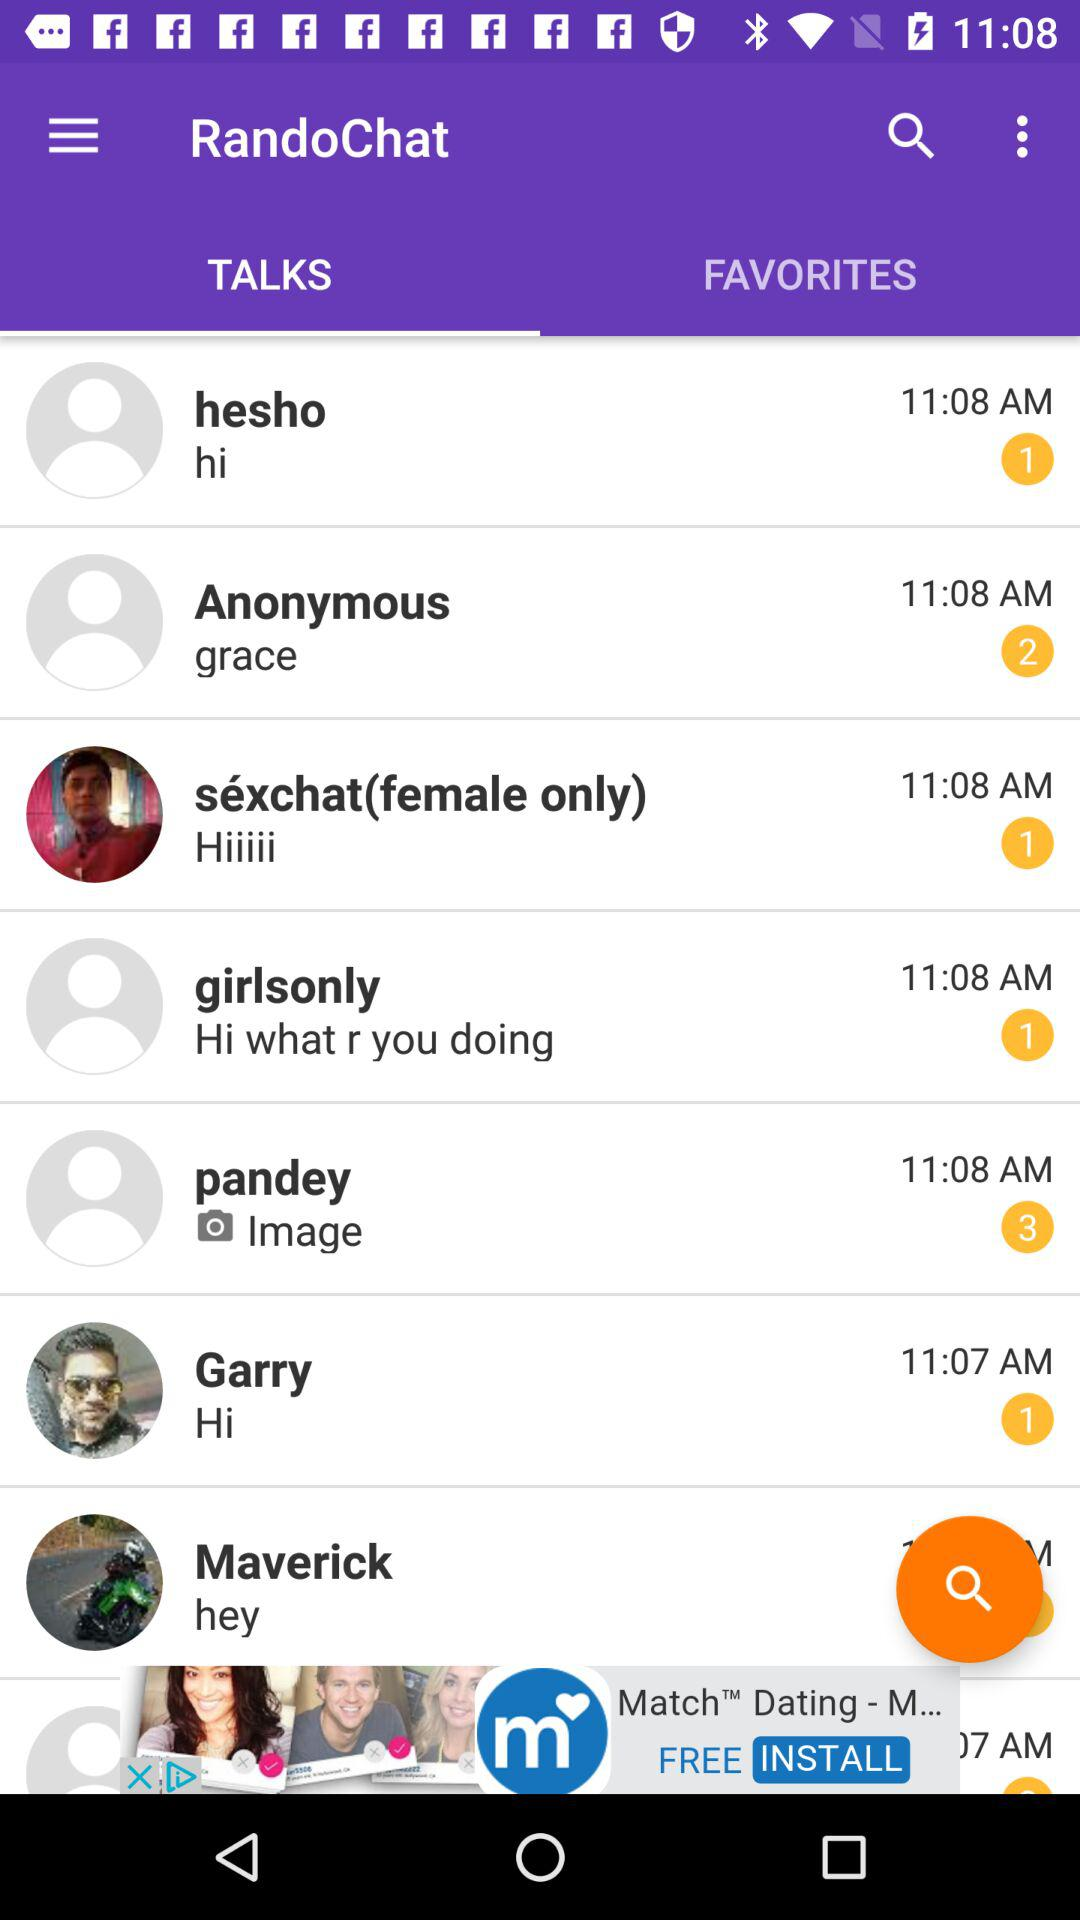How many messages have been received from Pandey? The number of messages that have been received from Pandey is 3. 